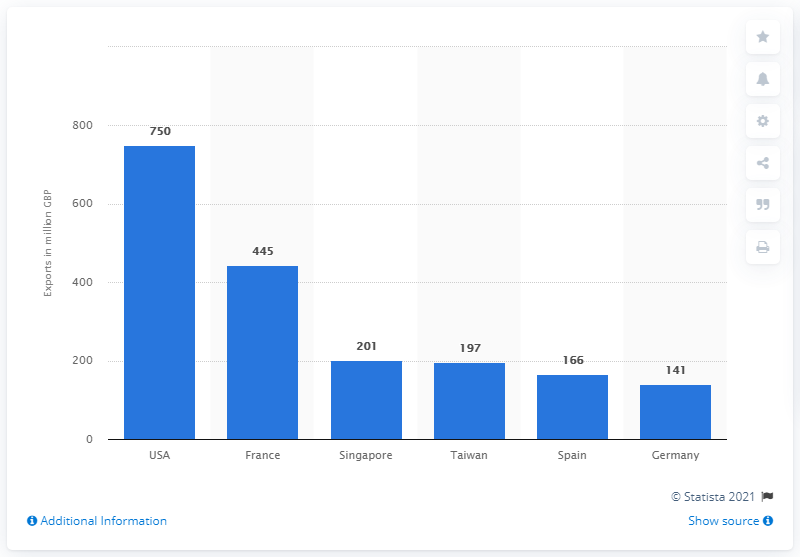Mention a couple of crucial points in this snapshot. In 2014, the value share of Scotch whisky in the United States was approximately 750.. 